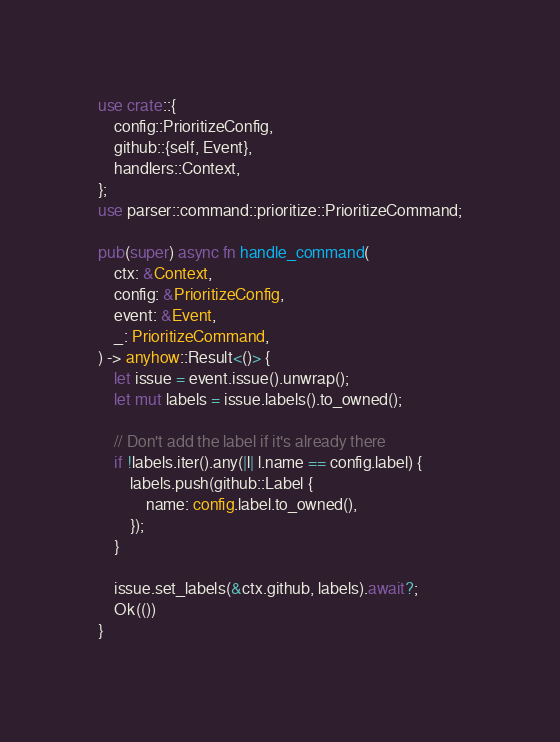<code> <loc_0><loc_0><loc_500><loc_500><_Rust_>use crate::{
    config::PrioritizeConfig,
    github::{self, Event},
    handlers::Context,
};
use parser::command::prioritize::PrioritizeCommand;

pub(super) async fn handle_command(
    ctx: &Context,
    config: &PrioritizeConfig,
    event: &Event,
    _: PrioritizeCommand,
) -> anyhow::Result<()> {
    let issue = event.issue().unwrap();
    let mut labels = issue.labels().to_owned();

    // Don't add the label if it's already there
    if !labels.iter().any(|l| l.name == config.label) {
        labels.push(github::Label {
            name: config.label.to_owned(),
        });
    }

    issue.set_labels(&ctx.github, labels).await?;
    Ok(())
}
</code> 